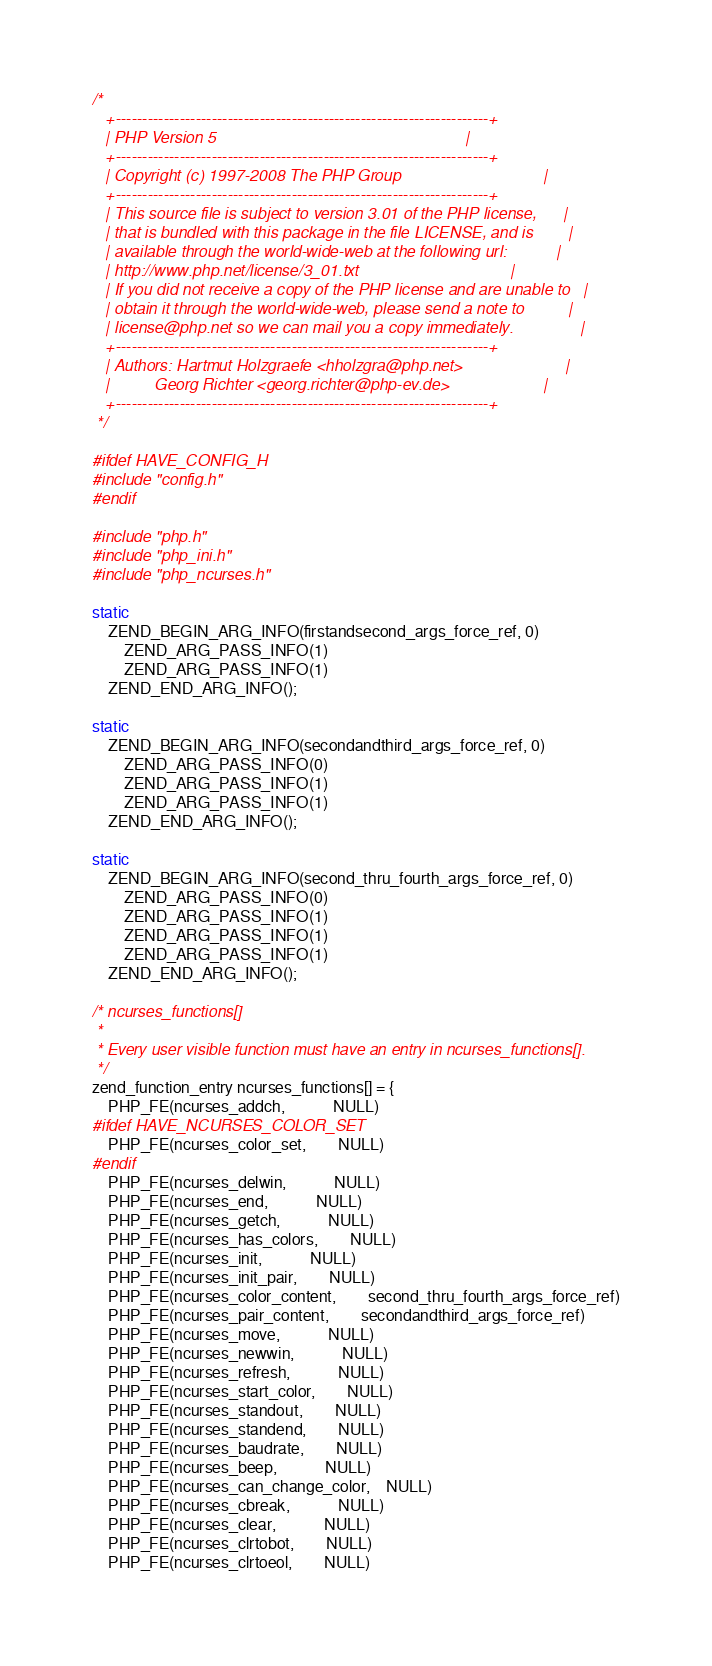<code> <loc_0><loc_0><loc_500><loc_500><_C_>/*
   +----------------------------------------------------------------------+
   | PHP Version 5                                                        |
   +----------------------------------------------------------------------+
   | Copyright (c) 1997-2008 The PHP Group                                |
   +----------------------------------------------------------------------+
   | This source file is subject to version 3.01 of the PHP license,      |
   | that is bundled with this package in the file LICENSE, and is        |
   | available through the world-wide-web at the following url:           |
   | http://www.php.net/license/3_01.txt                                  |
   | If you did not receive a copy of the PHP license and are unable to   |
   | obtain it through the world-wide-web, please send a note to          |
   | license@php.net so we can mail you a copy immediately.               |
   +----------------------------------------------------------------------+
   | Authors: Hartmut Holzgraefe <hholzgra@php.net>                       |
   |          Georg Richter <georg.richter@php-ev.de>                     |
   +----------------------------------------------------------------------+
 */

#ifdef HAVE_CONFIG_H
#include "config.h"
#endif

#include "php.h"
#include "php_ini.h"
#include "php_ncurses.h"

static 
	ZEND_BEGIN_ARG_INFO(firstandsecond_args_force_ref, 0)
		ZEND_ARG_PASS_INFO(1)
		ZEND_ARG_PASS_INFO(1)
	ZEND_END_ARG_INFO();

static
	ZEND_BEGIN_ARG_INFO(secondandthird_args_force_ref, 0)
		ZEND_ARG_PASS_INFO(0)
		ZEND_ARG_PASS_INFO(1)
		ZEND_ARG_PASS_INFO(1)
	ZEND_END_ARG_INFO();

static 
	ZEND_BEGIN_ARG_INFO(second_thru_fourth_args_force_ref, 0)
		ZEND_ARG_PASS_INFO(0)
		ZEND_ARG_PASS_INFO(1)
		ZEND_ARG_PASS_INFO(1)
		ZEND_ARG_PASS_INFO(1)
	ZEND_END_ARG_INFO();

/* ncurses_functions[]
 *
 * Every user visible function must have an entry in ncurses_functions[].
 */
zend_function_entry ncurses_functions[] = {
	PHP_FE(ncurses_addch,			NULL)
#ifdef HAVE_NCURSES_COLOR_SET
	PHP_FE(ncurses_color_set,		NULL)
#endif
	PHP_FE(ncurses_delwin,			NULL)
	PHP_FE(ncurses_end,			NULL)
	PHP_FE(ncurses_getch,			NULL)
	PHP_FE(ncurses_has_colors,		NULL)
	PHP_FE(ncurses_init,			NULL)
	PHP_FE(ncurses_init_pair,		NULL)
	PHP_FE(ncurses_color_content,		second_thru_fourth_args_force_ref)
	PHP_FE(ncurses_pair_content,		secondandthird_args_force_ref)
	PHP_FE(ncurses_move,			NULL)
	PHP_FE(ncurses_newwin,			NULL)
	PHP_FE(ncurses_refresh,			NULL)
	PHP_FE(ncurses_start_color,		NULL)
	PHP_FE(ncurses_standout,		NULL)
	PHP_FE(ncurses_standend,		NULL)
	PHP_FE(ncurses_baudrate,		NULL)
	PHP_FE(ncurses_beep,			NULL)
	PHP_FE(ncurses_can_change_color,	NULL)
	PHP_FE(ncurses_cbreak,			NULL)
	PHP_FE(ncurses_clear,			NULL)
	PHP_FE(ncurses_clrtobot,		NULL)
	PHP_FE(ncurses_clrtoeol,		NULL)</code> 